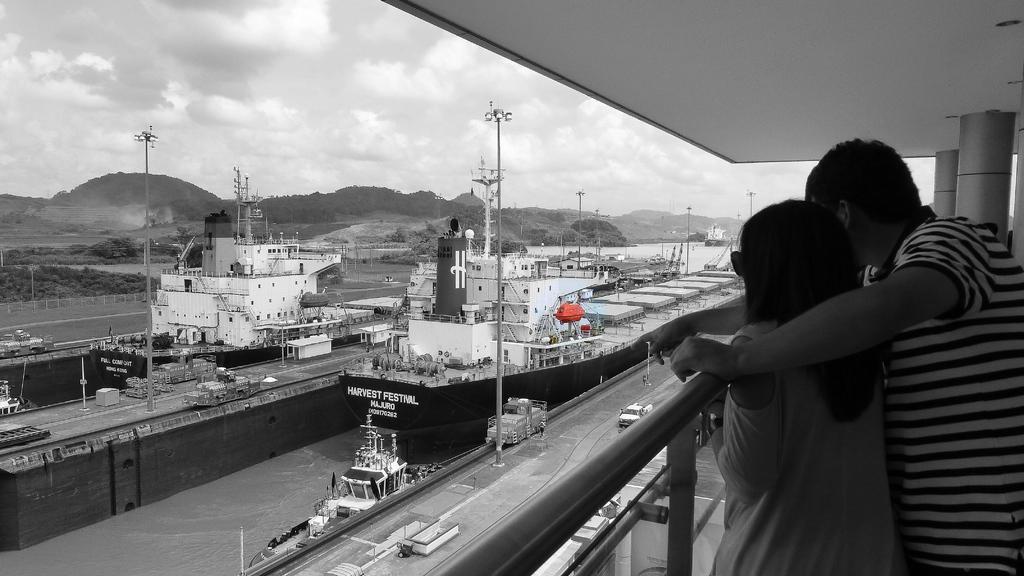Could you give a brief overview of what you see in this image? It is a black and white image, there are two people standing in the foreground and in front of them there is a shipyard, there are huge ships and other machines and vehicles. In the background there are mountains. 